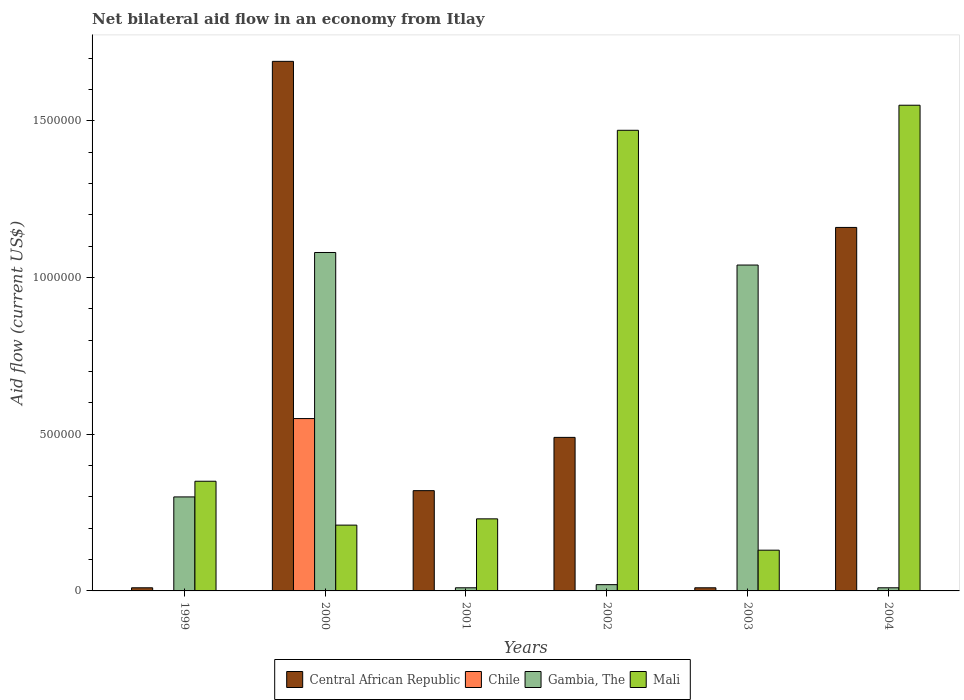How many groups of bars are there?
Your response must be concise. 6. How many bars are there on the 1st tick from the left?
Keep it short and to the point. 3. In how many cases, is the number of bars for a given year not equal to the number of legend labels?
Provide a succinct answer. 5. What is the net bilateral aid flow in Mali in 2003?
Your response must be concise. 1.30e+05. Across all years, what is the maximum net bilateral aid flow in Chile?
Your answer should be very brief. 5.50e+05. Across all years, what is the minimum net bilateral aid flow in Central African Republic?
Your answer should be compact. 10000. What is the total net bilateral aid flow in Mali in the graph?
Give a very brief answer. 3.94e+06. What is the difference between the net bilateral aid flow in Central African Republic in 1999 and that in 2002?
Offer a terse response. -4.80e+05. What is the average net bilateral aid flow in Central African Republic per year?
Offer a very short reply. 6.13e+05. In the year 2003, what is the difference between the net bilateral aid flow in Gambia, The and net bilateral aid flow in Central African Republic?
Your answer should be compact. 1.03e+06. In how many years, is the net bilateral aid flow in Central African Republic greater than 1400000 US$?
Provide a short and direct response. 1. What is the ratio of the net bilateral aid flow in Gambia, The in 1999 to that in 2003?
Keep it short and to the point. 0.29. Is the net bilateral aid flow in Mali in 1999 less than that in 2003?
Your answer should be compact. No. Is the difference between the net bilateral aid flow in Gambia, The in 2000 and 2003 greater than the difference between the net bilateral aid flow in Central African Republic in 2000 and 2003?
Offer a terse response. No. What is the difference between the highest and the lowest net bilateral aid flow in Chile?
Ensure brevity in your answer.  5.50e+05. Is the sum of the net bilateral aid flow in Central African Republic in 1999 and 2003 greater than the maximum net bilateral aid flow in Gambia, The across all years?
Provide a short and direct response. No. Is it the case that in every year, the sum of the net bilateral aid flow in Gambia, The and net bilateral aid flow in Mali is greater than the sum of net bilateral aid flow in Chile and net bilateral aid flow in Central African Republic?
Offer a very short reply. No. How many bars are there?
Ensure brevity in your answer.  19. How many years are there in the graph?
Your answer should be very brief. 6. What is the difference between two consecutive major ticks on the Y-axis?
Provide a succinct answer. 5.00e+05. Does the graph contain grids?
Offer a very short reply. No. What is the title of the graph?
Provide a succinct answer. Net bilateral aid flow in an economy from Itlay. What is the Aid flow (current US$) of Chile in 1999?
Give a very brief answer. 0. What is the Aid flow (current US$) in Gambia, The in 1999?
Provide a succinct answer. 3.00e+05. What is the Aid flow (current US$) in Central African Republic in 2000?
Your answer should be very brief. 1.69e+06. What is the Aid flow (current US$) in Chile in 2000?
Provide a succinct answer. 5.50e+05. What is the Aid flow (current US$) in Gambia, The in 2000?
Make the answer very short. 1.08e+06. What is the Aid flow (current US$) in Mali in 2000?
Provide a succinct answer. 2.10e+05. What is the Aid flow (current US$) in Chile in 2001?
Ensure brevity in your answer.  0. What is the Aid flow (current US$) in Gambia, The in 2002?
Offer a terse response. 2.00e+04. What is the Aid flow (current US$) of Mali in 2002?
Make the answer very short. 1.47e+06. What is the Aid flow (current US$) in Chile in 2003?
Your response must be concise. 0. What is the Aid flow (current US$) in Gambia, The in 2003?
Your answer should be very brief. 1.04e+06. What is the Aid flow (current US$) of Mali in 2003?
Provide a succinct answer. 1.30e+05. What is the Aid flow (current US$) in Central African Republic in 2004?
Give a very brief answer. 1.16e+06. What is the Aid flow (current US$) of Chile in 2004?
Offer a very short reply. 0. What is the Aid flow (current US$) in Gambia, The in 2004?
Keep it short and to the point. 10000. What is the Aid flow (current US$) in Mali in 2004?
Your answer should be very brief. 1.55e+06. Across all years, what is the maximum Aid flow (current US$) in Central African Republic?
Your answer should be compact. 1.69e+06. Across all years, what is the maximum Aid flow (current US$) of Chile?
Your response must be concise. 5.50e+05. Across all years, what is the maximum Aid flow (current US$) in Gambia, The?
Your answer should be compact. 1.08e+06. Across all years, what is the maximum Aid flow (current US$) in Mali?
Offer a terse response. 1.55e+06. Across all years, what is the minimum Aid flow (current US$) in Central African Republic?
Your answer should be very brief. 10000. Across all years, what is the minimum Aid flow (current US$) of Gambia, The?
Your answer should be very brief. 10000. Across all years, what is the minimum Aid flow (current US$) of Mali?
Keep it short and to the point. 1.30e+05. What is the total Aid flow (current US$) of Central African Republic in the graph?
Your answer should be compact. 3.68e+06. What is the total Aid flow (current US$) in Chile in the graph?
Provide a short and direct response. 5.50e+05. What is the total Aid flow (current US$) in Gambia, The in the graph?
Make the answer very short. 2.46e+06. What is the total Aid flow (current US$) in Mali in the graph?
Provide a short and direct response. 3.94e+06. What is the difference between the Aid flow (current US$) in Central African Republic in 1999 and that in 2000?
Provide a succinct answer. -1.68e+06. What is the difference between the Aid flow (current US$) of Gambia, The in 1999 and that in 2000?
Give a very brief answer. -7.80e+05. What is the difference between the Aid flow (current US$) of Mali in 1999 and that in 2000?
Keep it short and to the point. 1.40e+05. What is the difference between the Aid flow (current US$) of Central African Republic in 1999 and that in 2001?
Offer a very short reply. -3.10e+05. What is the difference between the Aid flow (current US$) in Mali in 1999 and that in 2001?
Your response must be concise. 1.20e+05. What is the difference between the Aid flow (current US$) of Central African Republic in 1999 and that in 2002?
Ensure brevity in your answer.  -4.80e+05. What is the difference between the Aid flow (current US$) of Mali in 1999 and that in 2002?
Your answer should be compact. -1.12e+06. What is the difference between the Aid flow (current US$) of Central African Republic in 1999 and that in 2003?
Provide a succinct answer. 0. What is the difference between the Aid flow (current US$) of Gambia, The in 1999 and that in 2003?
Provide a succinct answer. -7.40e+05. What is the difference between the Aid flow (current US$) in Central African Republic in 1999 and that in 2004?
Offer a very short reply. -1.15e+06. What is the difference between the Aid flow (current US$) of Mali in 1999 and that in 2004?
Your answer should be compact. -1.20e+06. What is the difference between the Aid flow (current US$) of Central African Republic in 2000 and that in 2001?
Your answer should be very brief. 1.37e+06. What is the difference between the Aid flow (current US$) in Gambia, The in 2000 and that in 2001?
Provide a succinct answer. 1.07e+06. What is the difference between the Aid flow (current US$) in Central African Republic in 2000 and that in 2002?
Ensure brevity in your answer.  1.20e+06. What is the difference between the Aid flow (current US$) in Gambia, The in 2000 and that in 2002?
Make the answer very short. 1.06e+06. What is the difference between the Aid flow (current US$) in Mali in 2000 and that in 2002?
Make the answer very short. -1.26e+06. What is the difference between the Aid flow (current US$) of Central African Republic in 2000 and that in 2003?
Your answer should be compact. 1.68e+06. What is the difference between the Aid flow (current US$) of Central African Republic in 2000 and that in 2004?
Offer a very short reply. 5.30e+05. What is the difference between the Aid flow (current US$) of Gambia, The in 2000 and that in 2004?
Your answer should be very brief. 1.07e+06. What is the difference between the Aid flow (current US$) of Mali in 2000 and that in 2004?
Your answer should be compact. -1.34e+06. What is the difference between the Aid flow (current US$) of Central African Republic in 2001 and that in 2002?
Your response must be concise. -1.70e+05. What is the difference between the Aid flow (current US$) of Gambia, The in 2001 and that in 2002?
Keep it short and to the point. -10000. What is the difference between the Aid flow (current US$) of Mali in 2001 and that in 2002?
Offer a terse response. -1.24e+06. What is the difference between the Aid flow (current US$) of Central African Republic in 2001 and that in 2003?
Ensure brevity in your answer.  3.10e+05. What is the difference between the Aid flow (current US$) of Gambia, The in 2001 and that in 2003?
Your response must be concise. -1.03e+06. What is the difference between the Aid flow (current US$) in Mali in 2001 and that in 2003?
Your response must be concise. 1.00e+05. What is the difference between the Aid flow (current US$) in Central African Republic in 2001 and that in 2004?
Provide a succinct answer. -8.40e+05. What is the difference between the Aid flow (current US$) of Mali in 2001 and that in 2004?
Your answer should be compact. -1.32e+06. What is the difference between the Aid flow (current US$) of Central African Republic in 2002 and that in 2003?
Give a very brief answer. 4.80e+05. What is the difference between the Aid flow (current US$) of Gambia, The in 2002 and that in 2003?
Give a very brief answer. -1.02e+06. What is the difference between the Aid flow (current US$) of Mali in 2002 and that in 2003?
Make the answer very short. 1.34e+06. What is the difference between the Aid flow (current US$) of Central African Republic in 2002 and that in 2004?
Make the answer very short. -6.70e+05. What is the difference between the Aid flow (current US$) in Central African Republic in 2003 and that in 2004?
Offer a terse response. -1.15e+06. What is the difference between the Aid flow (current US$) in Gambia, The in 2003 and that in 2004?
Provide a succinct answer. 1.03e+06. What is the difference between the Aid flow (current US$) of Mali in 2003 and that in 2004?
Ensure brevity in your answer.  -1.42e+06. What is the difference between the Aid flow (current US$) of Central African Republic in 1999 and the Aid flow (current US$) of Chile in 2000?
Provide a succinct answer. -5.40e+05. What is the difference between the Aid flow (current US$) in Central African Republic in 1999 and the Aid flow (current US$) in Gambia, The in 2000?
Your answer should be very brief. -1.07e+06. What is the difference between the Aid flow (current US$) in Central African Republic in 1999 and the Aid flow (current US$) in Mali in 2000?
Give a very brief answer. -2.00e+05. What is the difference between the Aid flow (current US$) of Gambia, The in 1999 and the Aid flow (current US$) of Mali in 2000?
Your response must be concise. 9.00e+04. What is the difference between the Aid flow (current US$) of Central African Republic in 1999 and the Aid flow (current US$) of Gambia, The in 2001?
Provide a succinct answer. 0. What is the difference between the Aid flow (current US$) of Central African Republic in 1999 and the Aid flow (current US$) of Mali in 2001?
Give a very brief answer. -2.20e+05. What is the difference between the Aid flow (current US$) of Central African Republic in 1999 and the Aid flow (current US$) of Mali in 2002?
Your response must be concise. -1.46e+06. What is the difference between the Aid flow (current US$) in Gambia, The in 1999 and the Aid flow (current US$) in Mali in 2002?
Keep it short and to the point. -1.17e+06. What is the difference between the Aid flow (current US$) in Central African Republic in 1999 and the Aid flow (current US$) in Gambia, The in 2003?
Your answer should be compact. -1.03e+06. What is the difference between the Aid flow (current US$) of Central African Republic in 1999 and the Aid flow (current US$) of Mali in 2003?
Ensure brevity in your answer.  -1.20e+05. What is the difference between the Aid flow (current US$) of Gambia, The in 1999 and the Aid flow (current US$) of Mali in 2003?
Make the answer very short. 1.70e+05. What is the difference between the Aid flow (current US$) in Central African Republic in 1999 and the Aid flow (current US$) in Mali in 2004?
Offer a terse response. -1.54e+06. What is the difference between the Aid flow (current US$) of Gambia, The in 1999 and the Aid flow (current US$) of Mali in 2004?
Provide a succinct answer. -1.25e+06. What is the difference between the Aid flow (current US$) in Central African Republic in 2000 and the Aid flow (current US$) in Gambia, The in 2001?
Ensure brevity in your answer.  1.68e+06. What is the difference between the Aid flow (current US$) of Central African Republic in 2000 and the Aid flow (current US$) of Mali in 2001?
Provide a short and direct response. 1.46e+06. What is the difference between the Aid flow (current US$) in Chile in 2000 and the Aid flow (current US$) in Gambia, The in 2001?
Offer a very short reply. 5.40e+05. What is the difference between the Aid flow (current US$) in Chile in 2000 and the Aid flow (current US$) in Mali in 2001?
Offer a very short reply. 3.20e+05. What is the difference between the Aid flow (current US$) of Gambia, The in 2000 and the Aid flow (current US$) of Mali in 2001?
Give a very brief answer. 8.50e+05. What is the difference between the Aid flow (current US$) of Central African Republic in 2000 and the Aid flow (current US$) of Gambia, The in 2002?
Ensure brevity in your answer.  1.67e+06. What is the difference between the Aid flow (current US$) of Central African Republic in 2000 and the Aid flow (current US$) of Mali in 2002?
Offer a terse response. 2.20e+05. What is the difference between the Aid flow (current US$) in Chile in 2000 and the Aid flow (current US$) in Gambia, The in 2002?
Give a very brief answer. 5.30e+05. What is the difference between the Aid flow (current US$) in Chile in 2000 and the Aid flow (current US$) in Mali in 2002?
Provide a succinct answer. -9.20e+05. What is the difference between the Aid flow (current US$) of Gambia, The in 2000 and the Aid flow (current US$) of Mali in 2002?
Your answer should be very brief. -3.90e+05. What is the difference between the Aid flow (current US$) in Central African Republic in 2000 and the Aid flow (current US$) in Gambia, The in 2003?
Offer a terse response. 6.50e+05. What is the difference between the Aid flow (current US$) of Central African Republic in 2000 and the Aid flow (current US$) of Mali in 2003?
Ensure brevity in your answer.  1.56e+06. What is the difference between the Aid flow (current US$) of Chile in 2000 and the Aid flow (current US$) of Gambia, The in 2003?
Keep it short and to the point. -4.90e+05. What is the difference between the Aid flow (current US$) in Gambia, The in 2000 and the Aid flow (current US$) in Mali in 2003?
Make the answer very short. 9.50e+05. What is the difference between the Aid flow (current US$) in Central African Republic in 2000 and the Aid flow (current US$) in Gambia, The in 2004?
Ensure brevity in your answer.  1.68e+06. What is the difference between the Aid flow (current US$) in Chile in 2000 and the Aid flow (current US$) in Gambia, The in 2004?
Offer a very short reply. 5.40e+05. What is the difference between the Aid flow (current US$) in Gambia, The in 2000 and the Aid flow (current US$) in Mali in 2004?
Ensure brevity in your answer.  -4.70e+05. What is the difference between the Aid flow (current US$) of Central African Republic in 2001 and the Aid flow (current US$) of Gambia, The in 2002?
Ensure brevity in your answer.  3.00e+05. What is the difference between the Aid flow (current US$) of Central African Republic in 2001 and the Aid flow (current US$) of Mali in 2002?
Provide a short and direct response. -1.15e+06. What is the difference between the Aid flow (current US$) in Gambia, The in 2001 and the Aid flow (current US$) in Mali in 2002?
Offer a very short reply. -1.46e+06. What is the difference between the Aid flow (current US$) in Central African Republic in 2001 and the Aid flow (current US$) in Gambia, The in 2003?
Offer a terse response. -7.20e+05. What is the difference between the Aid flow (current US$) in Gambia, The in 2001 and the Aid flow (current US$) in Mali in 2003?
Your answer should be very brief. -1.20e+05. What is the difference between the Aid flow (current US$) in Central African Republic in 2001 and the Aid flow (current US$) in Gambia, The in 2004?
Your answer should be very brief. 3.10e+05. What is the difference between the Aid flow (current US$) of Central African Republic in 2001 and the Aid flow (current US$) of Mali in 2004?
Ensure brevity in your answer.  -1.23e+06. What is the difference between the Aid flow (current US$) of Gambia, The in 2001 and the Aid flow (current US$) of Mali in 2004?
Keep it short and to the point. -1.54e+06. What is the difference between the Aid flow (current US$) of Central African Republic in 2002 and the Aid flow (current US$) of Gambia, The in 2003?
Your answer should be very brief. -5.50e+05. What is the difference between the Aid flow (current US$) of Central African Republic in 2002 and the Aid flow (current US$) of Mali in 2004?
Keep it short and to the point. -1.06e+06. What is the difference between the Aid flow (current US$) in Gambia, The in 2002 and the Aid flow (current US$) in Mali in 2004?
Provide a succinct answer. -1.53e+06. What is the difference between the Aid flow (current US$) in Central African Republic in 2003 and the Aid flow (current US$) in Mali in 2004?
Keep it short and to the point. -1.54e+06. What is the difference between the Aid flow (current US$) in Gambia, The in 2003 and the Aid flow (current US$) in Mali in 2004?
Your response must be concise. -5.10e+05. What is the average Aid flow (current US$) of Central African Republic per year?
Your response must be concise. 6.13e+05. What is the average Aid flow (current US$) of Chile per year?
Offer a terse response. 9.17e+04. What is the average Aid flow (current US$) in Mali per year?
Your answer should be very brief. 6.57e+05. In the year 1999, what is the difference between the Aid flow (current US$) of Central African Republic and Aid flow (current US$) of Gambia, The?
Keep it short and to the point. -2.90e+05. In the year 1999, what is the difference between the Aid flow (current US$) in Gambia, The and Aid flow (current US$) in Mali?
Ensure brevity in your answer.  -5.00e+04. In the year 2000, what is the difference between the Aid flow (current US$) of Central African Republic and Aid flow (current US$) of Chile?
Provide a succinct answer. 1.14e+06. In the year 2000, what is the difference between the Aid flow (current US$) in Central African Republic and Aid flow (current US$) in Gambia, The?
Keep it short and to the point. 6.10e+05. In the year 2000, what is the difference between the Aid flow (current US$) in Central African Republic and Aid flow (current US$) in Mali?
Your answer should be very brief. 1.48e+06. In the year 2000, what is the difference between the Aid flow (current US$) of Chile and Aid flow (current US$) of Gambia, The?
Provide a short and direct response. -5.30e+05. In the year 2000, what is the difference between the Aid flow (current US$) in Chile and Aid flow (current US$) in Mali?
Offer a terse response. 3.40e+05. In the year 2000, what is the difference between the Aid flow (current US$) in Gambia, The and Aid flow (current US$) in Mali?
Your answer should be compact. 8.70e+05. In the year 2001, what is the difference between the Aid flow (current US$) in Central African Republic and Aid flow (current US$) in Gambia, The?
Provide a short and direct response. 3.10e+05. In the year 2001, what is the difference between the Aid flow (current US$) of Gambia, The and Aid flow (current US$) of Mali?
Your response must be concise. -2.20e+05. In the year 2002, what is the difference between the Aid flow (current US$) in Central African Republic and Aid flow (current US$) in Mali?
Keep it short and to the point. -9.80e+05. In the year 2002, what is the difference between the Aid flow (current US$) in Gambia, The and Aid flow (current US$) in Mali?
Give a very brief answer. -1.45e+06. In the year 2003, what is the difference between the Aid flow (current US$) in Central African Republic and Aid flow (current US$) in Gambia, The?
Keep it short and to the point. -1.03e+06. In the year 2003, what is the difference between the Aid flow (current US$) in Central African Republic and Aid flow (current US$) in Mali?
Provide a succinct answer. -1.20e+05. In the year 2003, what is the difference between the Aid flow (current US$) of Gambia, The and Aid flow (current US$) of Mali?
Offer a very short reply. 9.10e+05. In the year 2004, what is the difference between the Aid flow (current US$) in Central African Republic and Aid flow (current US$) in Gambia, The?
Your answer should be very brief. 1.15e+06. In the year 2004, what is the difference between the Aid flow (current US$) of Central African Republic and Aid flow (current US$) of Mali?
Provide a succinct answer. -3.90e+05. In the year 2004, what is the difference between the Aid flow (current US$) of Gambia, The and Aid flow (current US$) of Mali?
Keep it short and to the point. -1.54e+06. What is the ratio of the Aid flow (current US$) of Central African Republic in 1999 to that in 2000?
Offer a very short reply. 0.01. What is the ratio of the Aid flow (current US$) in Gambia, The in 1999 to that in 2000?
Provide a short and direct response. 0.28. What is the ratio of the Aid flow (current US$) in Mali in 1999 to that in 2000?
Your answer should be very brief. 1.67. What is the ratio of the Aid flow (current US$) of Central African Republic in 1999 to that in 2001?
Keep it short and to the point. 0.03. What is the ratio of the Aid flow (current US$) of Mali in 1999 to that in 2001?
Your response must be concise. 1.52. What is the ratio of the Aid flow (current US$) in Central African Republic in 1999 to that in 2002?
Your answer should be very brief. 0.02. What is the ratio of the Aid flow (current US$) in Mali in 1999 to that in 2002?
Offer a terse response. 0.24. What is the ratio of the Aid flow (current US$) of Gambia, The in 1999 to that in 2003?
Make the answer very short. 0.29. What is the ratio of the Aid flow (current US$) of Mali in 1999 to that in 2003?
Give a very brief answer. 2.69. What is the ratio of the Aid flow (current US$) of Central African Republic in 1999 to that in 2004?
Ensure brevity in your answer.  0.01. What is the ratio of the Aid flow (current US$) of Mali in 1999 to that in 2004?
Offer a very short reply. 0.23. What is the ratio of the Aid flow (current US$) in Central African Republic in 2000 to that in 2001?
Your answer should be very brief. 5.28. What is the ratio of the Aid flow (current US$) in Gambia, The in 2000 to that in 2001?
Provide a succinct answer. 108. What is the ratio of the Aid flow (current US$) in Mali in 2000 to that in 2001?
Your answer should be compact. 0.91. What is the ratio of the Aid flow (current US$) of Central African Republic in 2000 to that in 2002?
Your answer should be very brief. 3.45. What is the ratio of the Aid flow (current US$) in Gambia, The in 2000 to that in 2002?
Keep it short and to the point. 54. What is the ratio of the Aid flow (current US$) of Mali in 2000 to that in 2002?
Your answer should be compact. 0.14. What is the ratio of the Aid flow (current US$) of Central African Republic in 2000 to that in 2003?
Offer a terse response. 169. What is the ratio of the Aid flow (current US$) in Gambia, The in 2000 to that in 2003?
Provide a short and direct response. 1.04. What is the ratio of the Aid flow (current US$) in Mali in 2000 to that in 2003?
Your response must be concise. 1.62. What is the ratio of the Aid flow (current US$) in Central African Republic in 2000 to that in 2004?
Your answer should be compact. 1.46. What is the ratio of the Aid flow (current US$) of Gambia, The in 2000 to that in 2004?
Give a very brief answer. 108. What is the ratio of the Aid flow (current US$) in Mali in 2000 to that in 2004?
Provide a succinct answer. 0.14. What is the ratio of the Aid flow (current US$) of Central African Republic in 2001 to that in 2002?
Provide a succinct answer. 0.65. What is the ratio of the Aid flow (current US$) of Mali in 2001 to that in 2002?
Your answer should be very brief. 0.16. What is the ratio of the Aid flow (current US$) of Gambia, The in 2001 to that in 2003?
Your answer should be compact. 0.01. What is the ratio of the Aid flow (current US$) of Mali in 2001 to that in 2003?
Offer a very short reply. 1.77. What is the ratio of the Aid flow (current US$) of Central African Republic in 2001 to that in 2004?
Your answer should be very brief. 0.28. What is the ratio of the Aid flow (current US$) in Mali in 2001 to that in 2004?
Provide a succinct answer. 0.15. What is the ratio of the Aid flow (current US$) in Central African Republic in 2002 to that in 2003?
Ensure brevity in your answer.  49. What is the ratio of the Aid flow (current US$) of Gambia, The in 2002 to that in 2003?
Provide a short and direct response. 0.02. What is the ratio of the Aid flow (current US$) of Mali in 2002 to that in 2003?
Your answer should be compact. 11.31. What is the ratio of the Aid flow (current US$) in Central African Republic in 2002 to that in 2004?
Your response must be concise. 0.42. What is the ratio of the Aid flow (current US$) of Mali in 2002 to that in 2004?
Offer a terse response. 0.95. What is the ratio of the Aid flow (current US$) in Central African Republic in 2003 to that in 2004?
Make the answer very short. 0.01. What is the ratio of the Aid flow (current US$) in Gambia, The in 2003 to that in 2004?
Provide a short and direct response. 104. What is the ratio of the Aid flow (current US$) in Mali in 2003 to that in 2004?
Provide a short and direct response. 0.08. What is the difference between the highest and the second highest Aid flow (current US$) in Central African Republic?
Your answer should be compact. 5.30e+05. What is the difference between the highest and the lowest Aid flow (current US$) of Central African Republic?
Keep it short and to the point. 1.68e+06. What is the difference between the highest and the lowest Aid flow (current US$) of Chile?
Give a very brief answer. 5.50e+05. What is the difference between the highest and the lowest Aid flow (current US$) in Gambia, The?
Your response must be concise. 1.07e+06. What is the difference between the highest and the lowest Aid flow (current US$) of Mali?
Your response must be concise. 1.42e+06. 